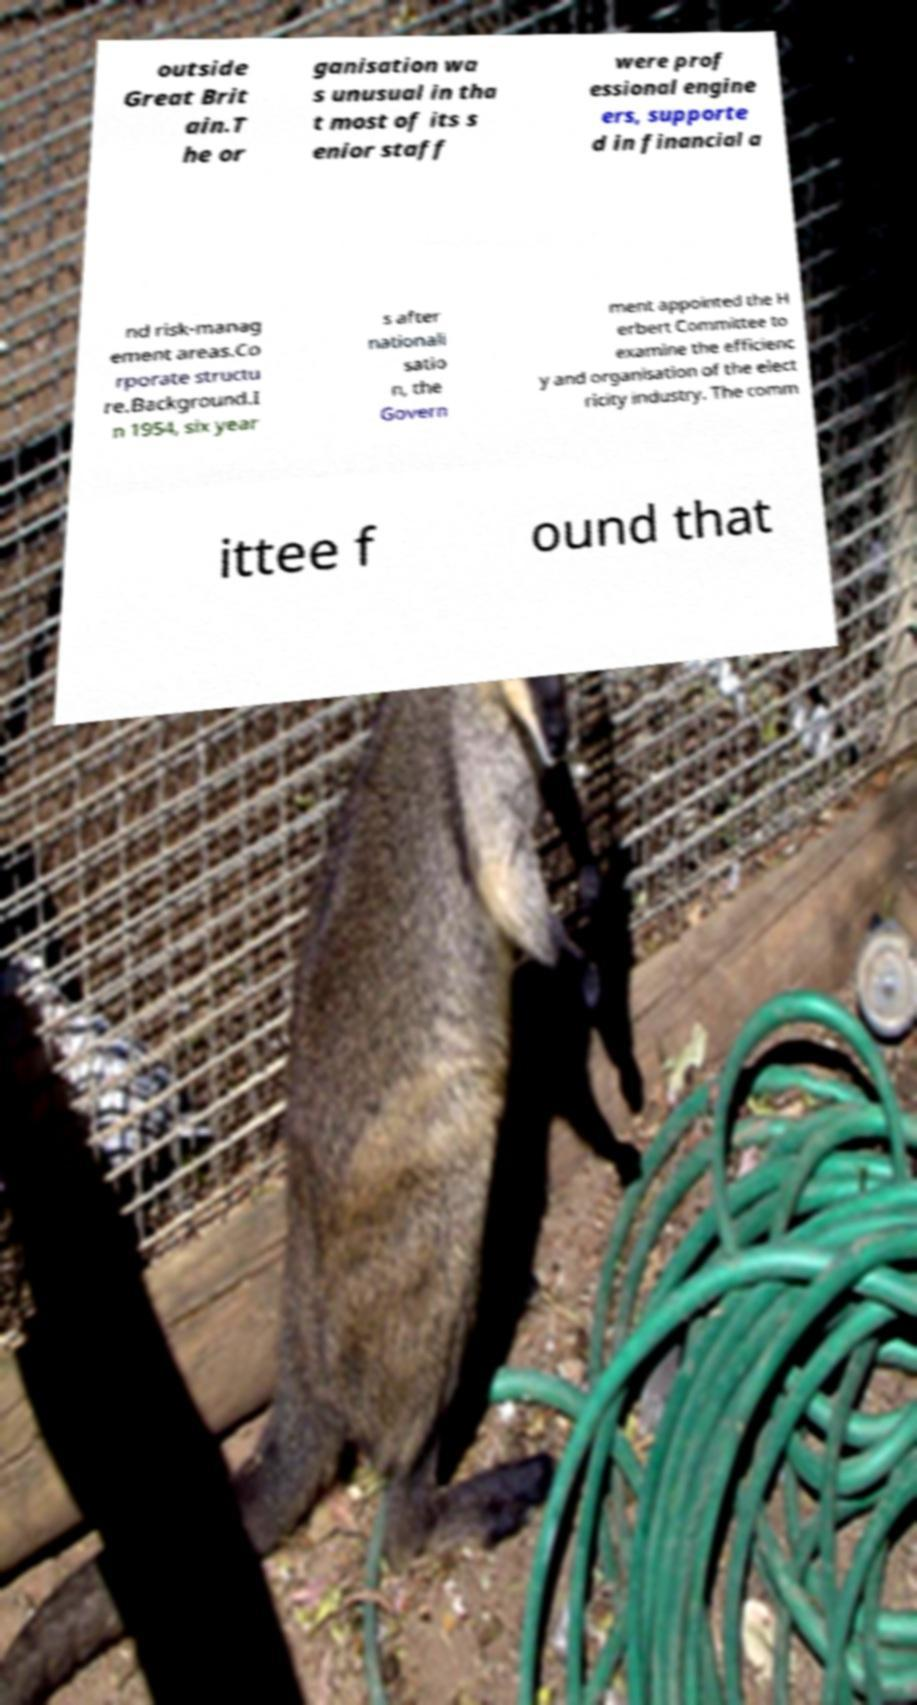Could you extract and type out the text from this image? outside Great Brit ain.T he or ganisation wa s unusual in tha t most of its s enior staff were prof essional engine ers, supporte d in financial a nd risk-manag ement areas.Co rporate structu re.Background.I n 1954, six year s after nationali satio n, the Govern ment appointed the H erbert Committee to examine the efficienc y and organisation of the elect ricity industry. The comm ittee f ound that 